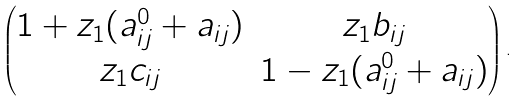<formula> <loc_0><loc_0><loc_500><loc_500>\left ( \begin{matrix} 1 + z _ { 1 } ( a ^ { 0 } _ { i j } + a _ { i j } ) & z _ { 1 } b _ { i j } \\ z _ { 1 } c _ { i j } & 1 - z _ { 1 } ( a ^ { 0 } _ { i j } + a _ { i j } ) \end{matrix} \right ) .</formula> 